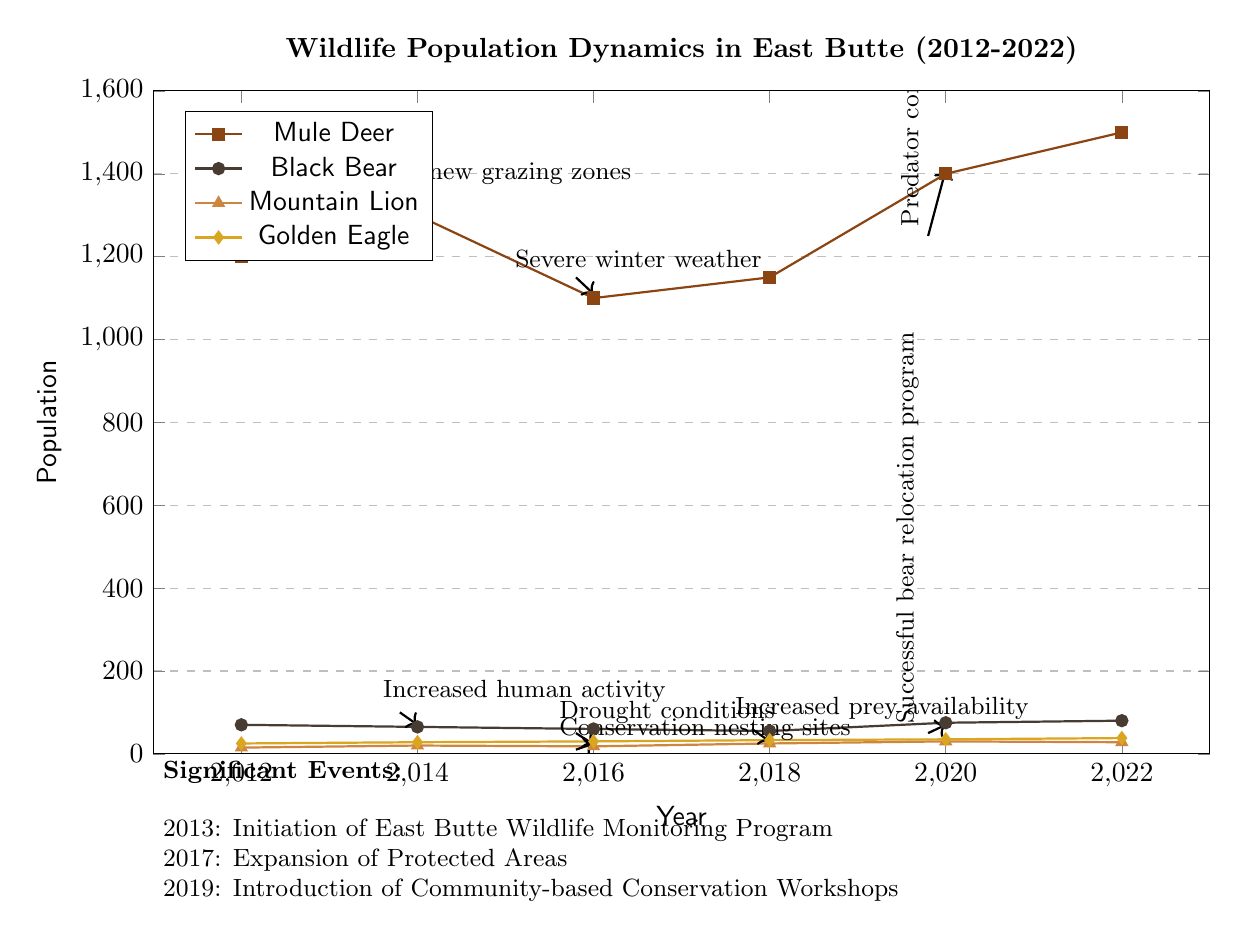What was the population of Mule Deer in 2022? The diagram shows a data point for Mule Deer in the year 2022 at the coordinate (2022, 1500), which indicates the population was 1500.
Answer: 1500 What significant event occurred in 2013? The diagram notes "Initiation of East Butte Wildlife Monitoring Program" as the significant event for the year 2013.
Answer: Initiation of East Butte Wildlife Monitoring Program How much did the Black Bear population decline from 2012 to 2018? In 2012, the Black Bear population was 70, and by 2018 it decreased to 55. The decline is calculated as 70 - 55 = 15.
Answer: 15 What was the highest population recorded for Mountain Lions during the decade? The highest population for Mountain Lions is found in 2018, where the diagram shows a recorded population of 25 at that point.
Answer: 25 What conservation effort occurred in 2015? The diagram illustrates "Conservation nesting sites" as the conservation effort that took place in 2015, marked by an annotation.
Answer: Conservation nesting sites How did the introduction of predator control measures affect the Mule Deer population? The diagram shows that after the predator control measures in 2019, the Mule Deer population increased from 1250 in 2019 to 1400 in 2020, indicating a positive impact.
Answer: Increased In what year did the Black Bear population begin to increase after a decline? According to the diagram, the Black Bear population decreased until 2018 (55) and then increased in 2020 to 75, indicating the first rise after the decline happened in 2020.
Answer: 2020 What trend can be observed about the Golden Eagle population over the decade? The Golden Eagle population consistently increased over the decade, rising from 25 in 2012 to 38 in 2022, indicating a steady upward trend across the entire period.
Answer: Consistent increase What was the effect of drought conditions on the population of Golden Eagles? The diagram shows that drought conditions in 2015 led to a population decline, indicating negative effects. Between 2015 and 2016, their population went from 25 to 30, which did not see a significant decline.
Answer: No significant decline 